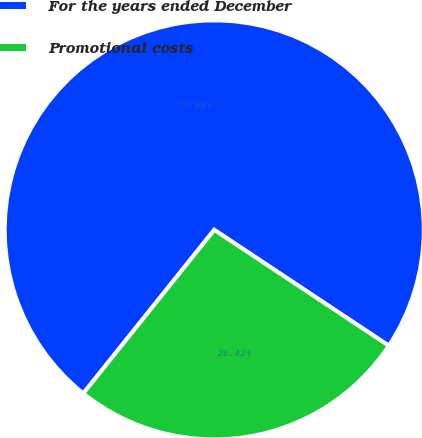Convert chart. <chart><loc_0><loc_0><loc_500><loc_500><pie_chart><fcel>For the years ended December<fcel>Promotional costs<nl><fcel>73.58%<fcel>26.42%<nl></chart> 